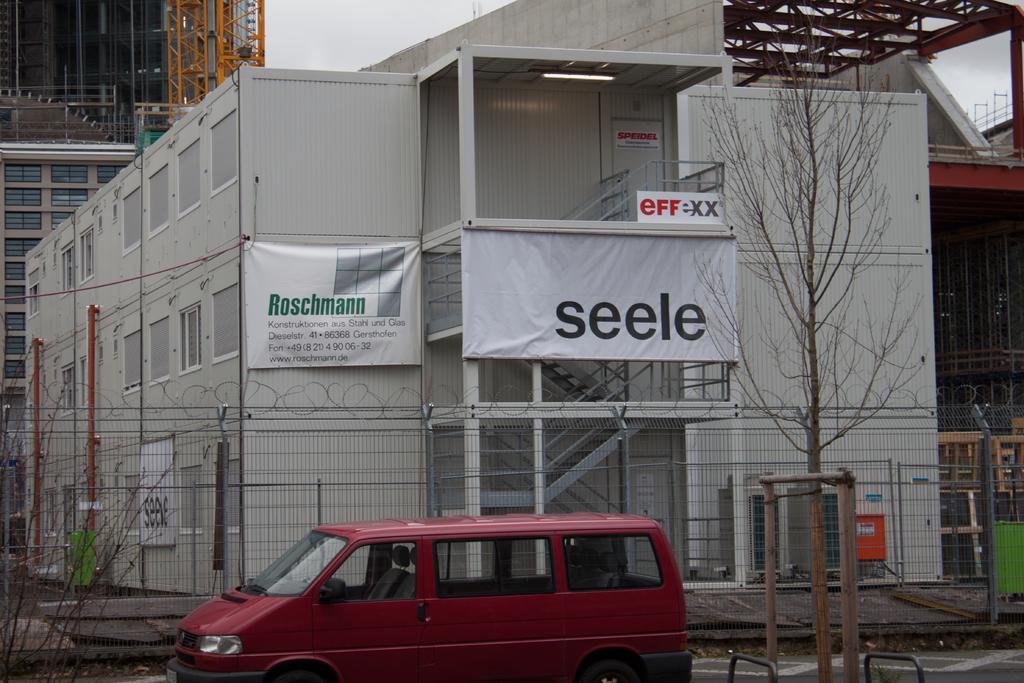Could you give a brief overview of what you see in this image? As we can see in the image there are buildings, trees, fence, banners and a van. On the top there is sky. 